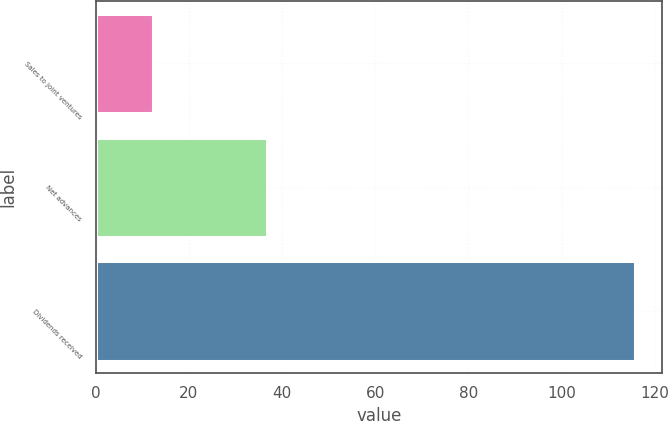Convert chart. <chart><loc_0><loc_0><loc_500><loc_500><bar_chart><fcel>Sales to joint ventures<fcel>Net advances<fcel>Dividends received<nl><fcel>12.3<fcel>36.7<fcel>115.7<nl></chart> 